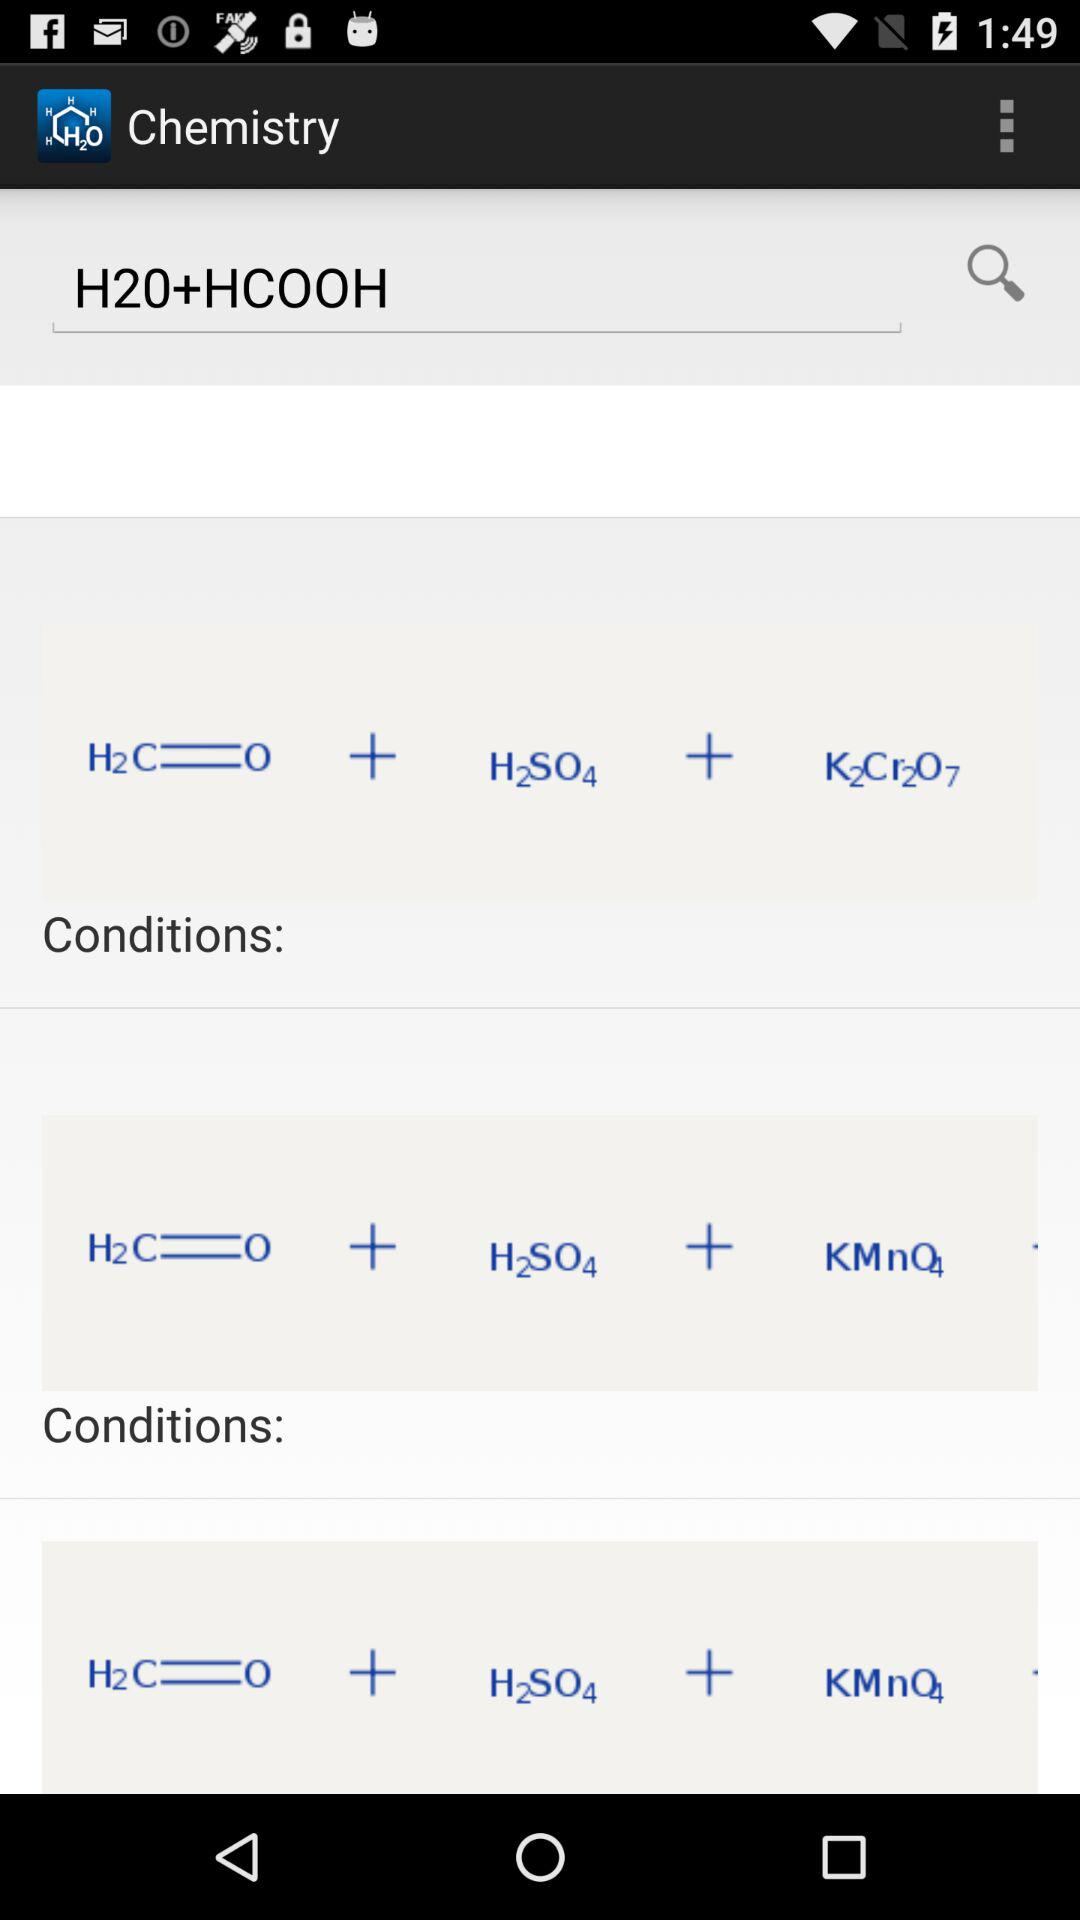How many more conditions are there in the third equation than in the first equation?
Answer the question using a single word or phrase. 1 